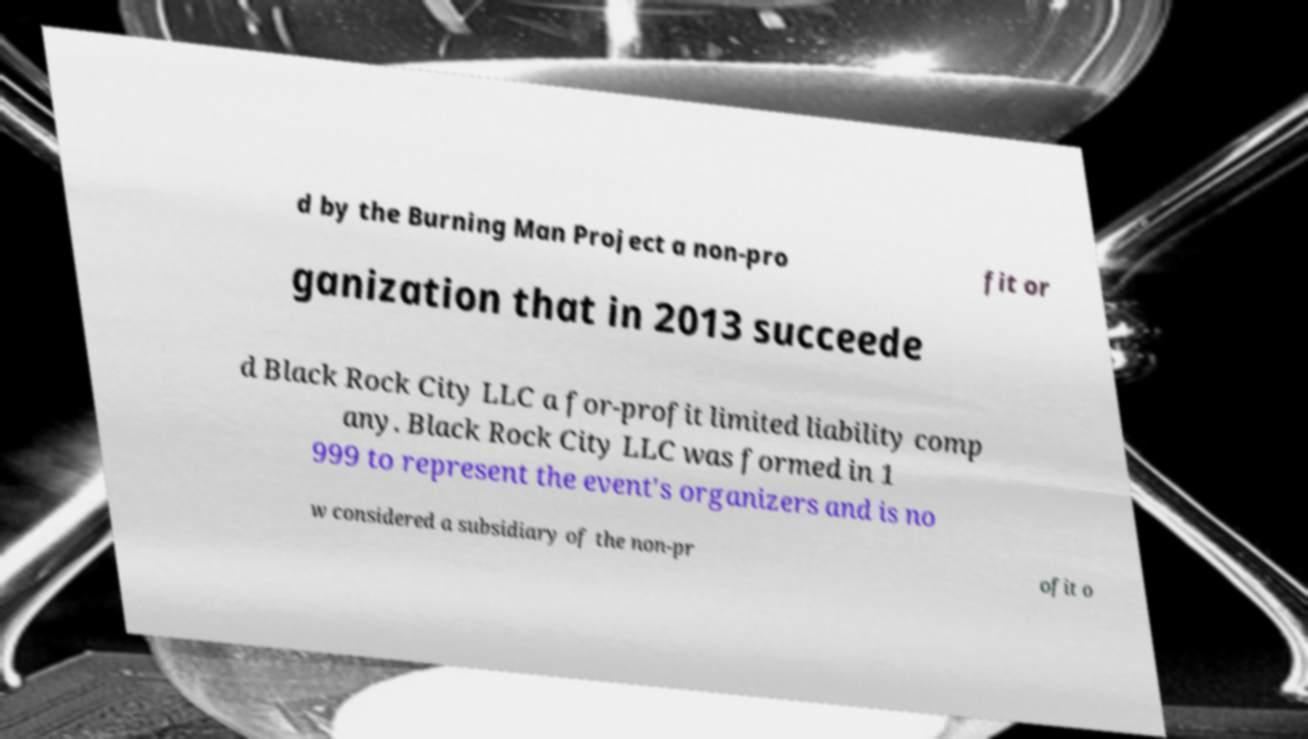I need the written content from this picture converted into text. Can you do that? d by the Burning Man Project a non-pro fit or ganization that in 2013 succeede d Black Rock City LLC a for-profit limited liability comp any. Black Rock City LLC was formed in 1 999 to represent the event's organizers and is no w considered a subsidiary of the non-pr ofit o 